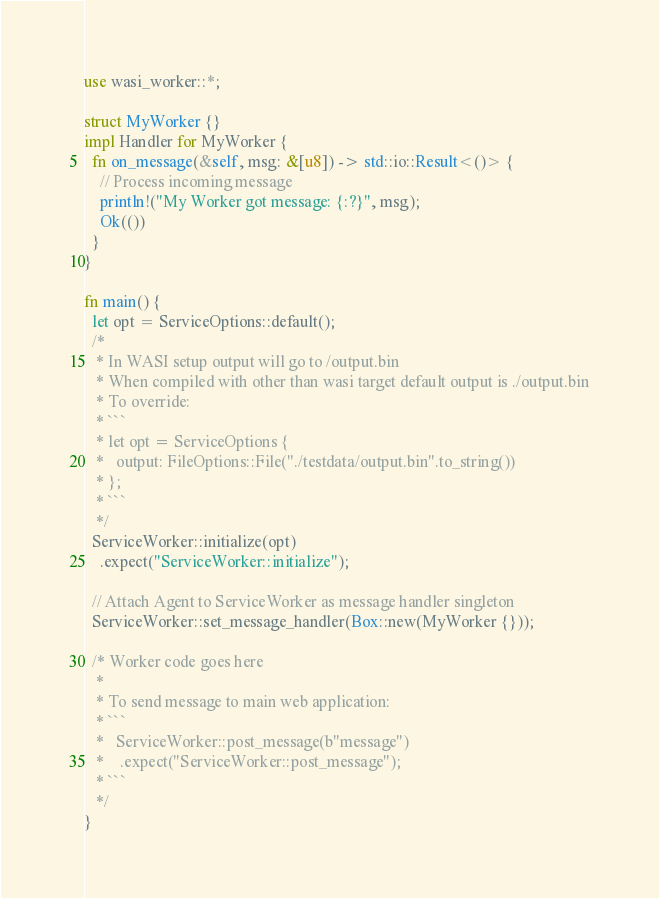Convert code to text. <code><loc_0><loc_0><loc_500><loc_500><_Rust_>use wasi_worker::*;

struct MyWorker {}
impl Handler for MyWorker {
  fn on_message(&self, msg: &[u8]) -> std::io::Result<()> {
    // Process incoming message
    println!("My Worker got message: {:?}", msg);
    Ok(())
  }
}

fn main() {
  let opt = ServiceOptions::default();
  /* 
   * In WASI setup output will go to /output.bin
   * When compiled with other than wasi target default output is ./output.bin
   * To override:
   * ```
   * let opt = ServiceOptions { 
   *   output: FileOptions::File("./testdata/output.bin".to_string()) 
   * };
   * ```
   */
  ServiceWorker::initialize(opt)
    .expect("ServiceWorker::initialize");

  // Attach Agent to ServiceWorker as message handler singleton
  ServiceWorker::set_message_handler(Box::new(MyWorker {}));

  /* Worker code goes here
   *
   * To send message to main web application:
   * ```
   *   ServiceWorker::post_message(b"message")
   *    .expect("ServiceWorker::post_message");
   * ```
   */
}
</code> 